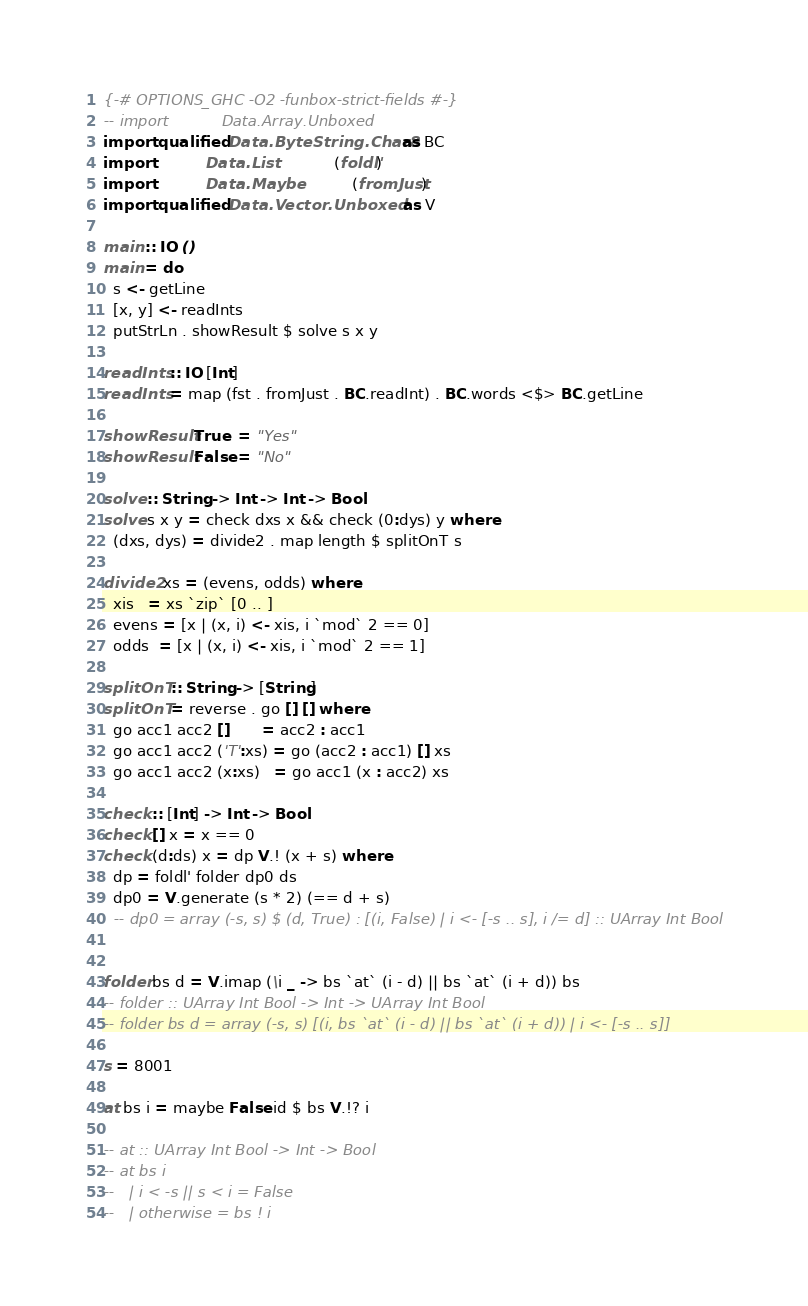Convert code to text. <code><loc_0><loc_0><loc_500><loc_500><_Haskell_>{-# OPTIONS_GHC -O2 -funbox-strict-fields #-}
-- import           Data.Array.Unboxed
import qualified Data.ByteString.Char8 as BC
import           Data.List             (foldl')
import           Data.Maybe            (fromJust)
import qualified Data.Vector.Unboxed   as V

main :: IO ()
main = do
  s <- getLine
  [x, y] <- readInts
  putStrLn . showResult $ solve s x y

readInts :: IO [Int]
readInts = map (fst . fromJust . BC.readInt) . BC.words <$> BC.getLine

showResult True  = "Yes"
showResult False = "No"

solve :: String -> Int -> Int -> Bool
solve s x y = check dxs x && check (0:dys) y where
  (dxs, dys) = divide2 . map length $ splitOnT s

divide2 xs = (evens, odds) where
  xis   = xs `zip` [0 .. ]
  evens = [x | (x, i) <- xis, i `mod` 2 == 0]
  odds  = [x | (x, i) <- xis, i `mod` 2 == 1]

splitOnT :: String -> [String]
splitOnT = reverse . go [] [] where
  go acc1 acc2 []       = acc2 : acc1
  go acc1 acc2 ('T':xs) = go (acc2 : acc1) [] xs
  go acc1 acc2 (x:xs)   = go acc1 (x : acc2) xs

check :: [Int] -> Int -> Bool
check [] x = x == 0
check (d:ds) x = dp V.! (x + s) where
  dp = foldl' folder dp0 ds
  dp0 = V.generate (s * 2) (== d + s)
  -- dp0 = array (-s, s) $ (d, True) : [(i, False) | i <- [-s .. s], i /= d] :: UArray Int Bool


folder bs d = V.imap (\i _ -> bs `at` (i - d) || bs `at` (i + d)) bs
-- folder :: UArray Int Bool -> Int -> UArray Int Bool
-- folder bs d = array (-s, s) [(i, bs `at` (i - d) || bs `at` (i + d)) | i <- [-s .. s]]

s = 8001

at bs i = maybe False id $ bs V.!? i

-- at :: UArray Int Bool -> Int -> Bool
-- at bs i
--   | i < -s || s < i = False
--   | otherwise = bs ! i
</code> 